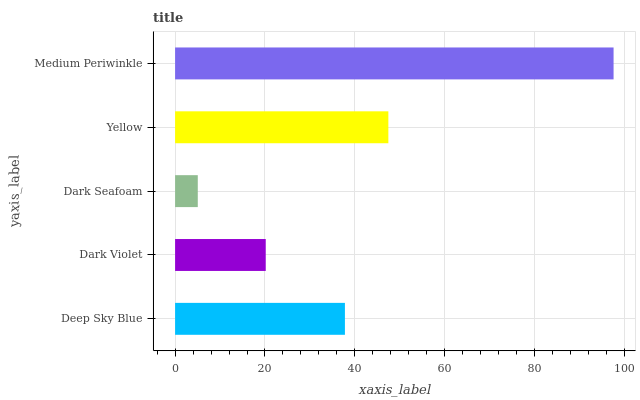Is Dark Seafoam the minimum?
Answer yes or no. Yes. Is Medium Periwinkle the maximum?
Answer yes or no. Yes. Is Dark Violet the minimum?
Answer yes or no. No. Is Dark Violet the maximum?
Answer yes or no. No. Is Deep Sky Blue greater than Dark Violet?
Answer yes or no. Yes. Is Dark Violet less than Deep Sky Blue?
Answer yes or no. Yes. Is Dark Violet greater than Deep Sky Blue?
Answer yes or no. No. Is Deep Sky Blue less than Dark Violet?
Answer yes or no. No. Is Deep Sky Blue the high median?
Answer yes or no. Yes. Is Deep Sky Blue the low median?
Answer yes or no. Yes. Is Dark Seafoam the high median?
Answer yes or no. No. Is Dark Violet the low median?
Answer yes or no. No. 